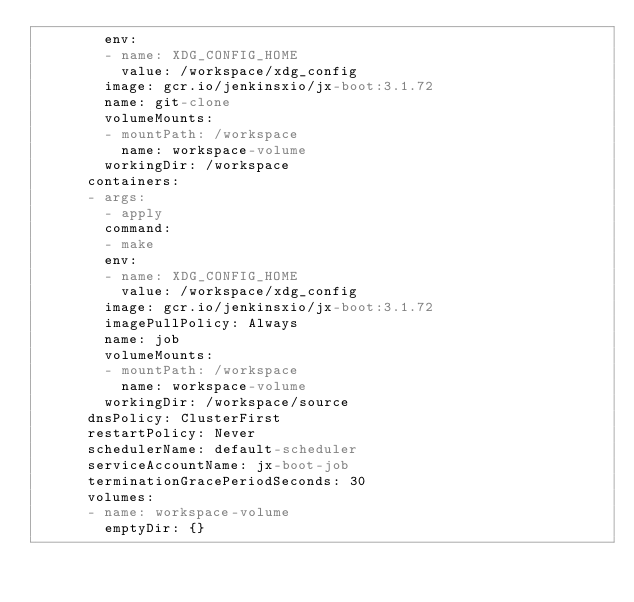<code> <loc_0><loc_0><loc_500><loc_500><_YAML_>        env:
        - name: XDG_CONFIG_HOME
          value: /workspace/xdg_config
        image: gcr.io/jenkinsxio/jx-boot:3.1.72
        name: git-clone
        volumeMounts:
        - mountPath: /workspace
          name: workspace-volume
        workingDir: /workspace
      containers:
      - args:
        - apply
        command:
        - make
        env:
        - name: XDG_CONFIG_HOME
          value: /workspace/xdg_config
        image: gcr.io/jenkinsxio/jx-boot:3.1.72
        imagePullPolicy: Always
        name: job
        volumeMounts:
        - mountPath: /workspace
          name: workspace-volume
        workingDir: /workspace/source
      dnsPolicy: ClusterFirst
      restartPolicy: Never
      schedulerName: default-scheduler
      serviceAccountName: jx-boot-job
      terminationGracePeriodSeconds: 30
      volumes:
      - name: workspace-volume
        emptyDir: {}
</code> 